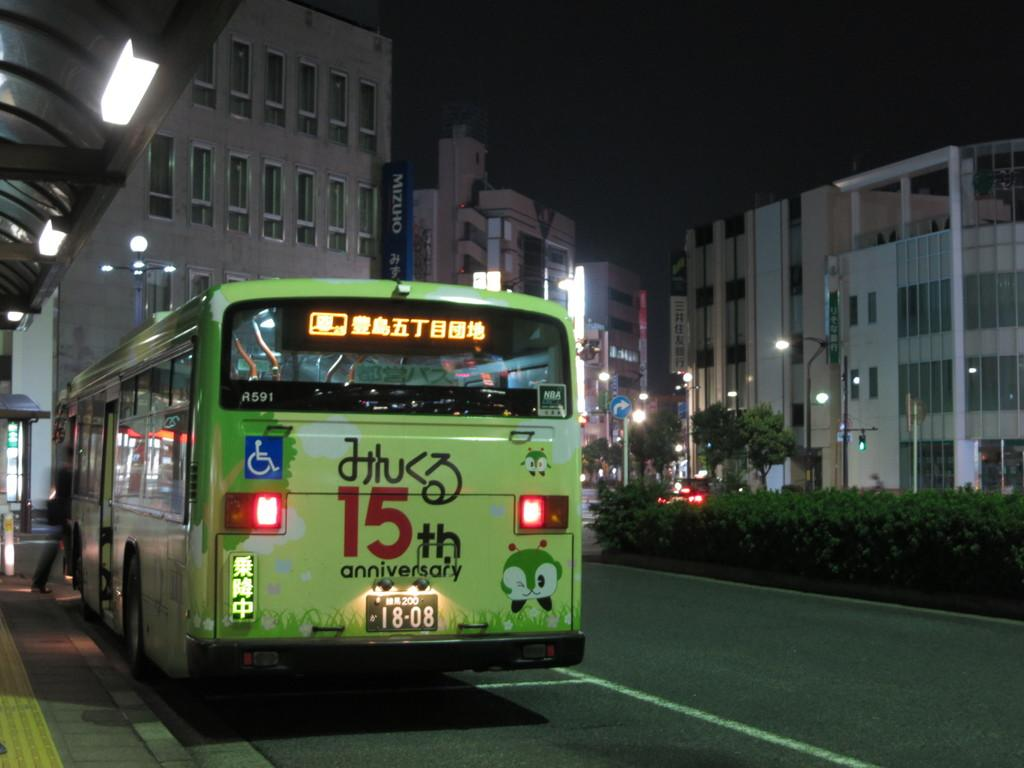<image>
Create a compact narrative representing the image presented. A green bus with a 15th anniversary sign on it is on the road. 